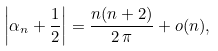<formula> <loc_0><loc_0><loc_500><loc_500>\left | \alpha _ { n } + \frac { 1 } { 2 } \right | = \frac { n ( n + 2 ) } { 2 \, \pi } + o ( n ) ,</formula> 